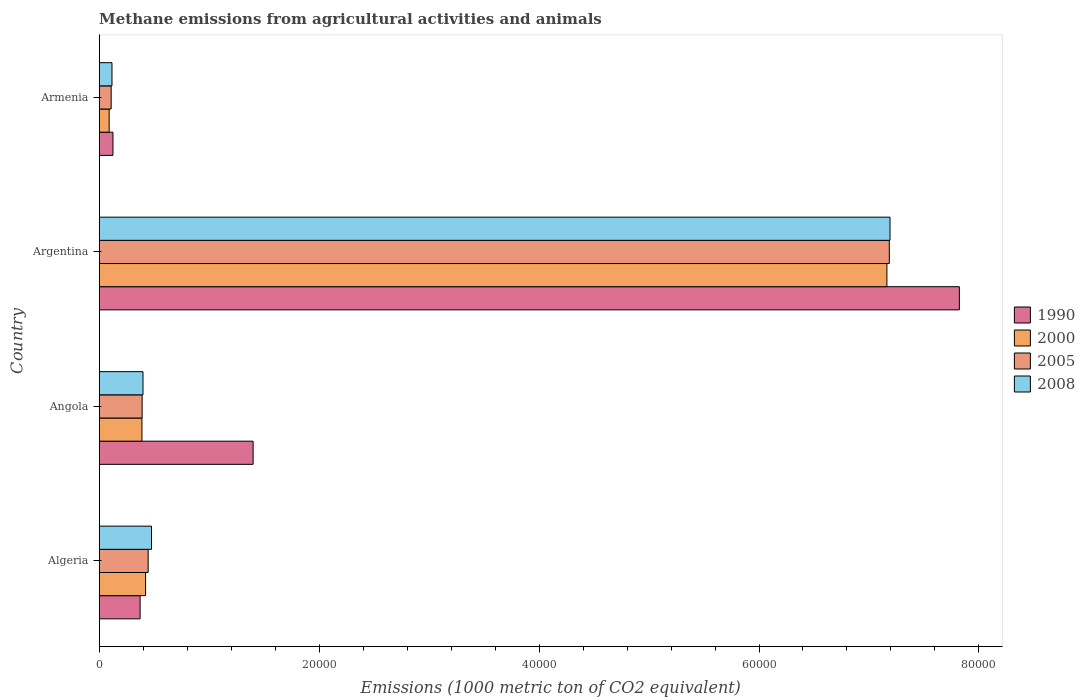Are the number of bars on each tick of the Y-axis equal?
Ensure brevity in your answer.  Yes. How many bars are there on the 4th tick from the top?
Your response must be concise. 4. How many bars are there on the 2nd tick from the bottom?
Offer a very short reply. 4. What is the label of the 1st group of bars from the top?
Offer a very short reply. Armenia. What is the amount of methane emitted in 2005 in Angola?
Your response must be concise. 3902.3. Across all countries, what is the maximum amount of methane emitted in 2008?
Make the answer very short. 7.19e+04. Across all countries, what is the minimum amount of methane emitted in 2005?
Provide a short and direct response. 1086. In which country was the amount of methane emitted in 2005 maximum?
Offer a terse response. Argentina. In which country was the amount of methane emitted in 2008 minimum?
Ensure brevity in your answer.  Armenia. What is the total amount of methane emitted in 1990 in the graph?
Offer a terse response. 9.72e+04. What is the difference between the amount of methane emitted in 1990 in Algeria and that in Angola?
Give a very brief answer. -1.03e+04. What is the difference between the amount of methane emitted in 2000 in Argentina and the amount of methane emitted in 2008 in Armenia?
Your answer should be compact. 7.05e+04. What is the average amount of methane emitted in 2005 per country?
Provide a short and direct response. 2.03e+04. What is the difference between the amount of methane emitted in 2000 and amount of methane emitted in 1990 in Argentina?
Offer a terse response. -6588.6. In how many countries, is the amount of methane emitted in 2005 greater than 12000 1000 metric ton?
Offer a very short reply. 1. What is the ratio of the amount of methane emitted in 1990 in Argentina to that in Armenia?
Provide a short and direct response. 62.56. Is the amount of methane emitted in 2005 in Algeria less than that in Argentina?
Make the answer very short. Yes. Is the difference between the amount of methane emitted in 2000 in Angola and Armenia greater than the difference between the amount of methane emitted in 1990 in Angola and Armenia?
Keep it short and to the point. No. What is the difference between the highest and the second highest amount of methane emitted in 2005?
Offer a very short reply. 6.74e+04. What is the difference between the highest and the lowest amount of methane emitted in 2005?
Offer a very short reply. 7.08e+04. In how many countries, is the amount of methane emitted in 1990 greater than the average amount of methane emitted in 1990 taken over all countries?
Offer a terse response. 1. Is the sum of the amount of methane emitted in 2005 in Algeria and Armenia greater than the maximum amount of methane emitted in 2000 across all countries?
Make the answer very short. No. What does the 2nd bar from the bottom in Armenia represents?
Your response must be concise. 2000. Is it the case that in every country, the sum of the amount of methane emitted in 1990 and amount of methane emitted in 2005 is greater than the amount of methane emitted in 2008?
Give a very brief answer. Yes. How many bars are there?
Offer a very short reply. 16. Are all the bars in the graph horizontal?
Provide a short and direct response. Yes. How many countries are there in the graph?
Provide a succinct answer. 4. Where does the legend appear in the graph?
Offer a very short reply. Center right. What is the title of the graph?
Your answer should be compact. Methane emissions from agricultural activities and animals. Does "2013" appear as one of the legend labels in the graph?
Give a very brief answer. No. What is the label or title of the X-axis?
Ensure brevity in your answer.  Emissions (1000 metric ton of CO2 equivalent). What is the label or title of the Y-axis?
Provide a succinct answer. Country. What is the Emissions (1000 metric ton of CO2 equivalent) in 1990 in Algeria?
Offer a very short reply. 3718.9. What is the Emissions (1000 metric ton of CO2 equivalent) of 2000 in Algeria?
Your answer should be very brief. 4216.3. What is the Emissions (1000 metric ton of CO2 equivalent) in 2005 in Algeria?
Ensure brevity in your answer.  4452.1. What is the Emissions (1000 metric ton of CO2 equivalent) of 2008 in Algeria?
Provide a succinct answer. 4754.7. What is the Emissions (1000 metric ton of CO2 equivalent) of 1990 in Angola?
Ensure brevity in your answer.  1.40e+04. What is the Emissions (1000 metric ton of CO2 equivalent) of 2000 in Angola?
Your answer should be very brief. 3884.4. What is the Emissions (1000 metric ton of CO2 equivalent) in 2005 in Angola?
Make the answer very short. 3902.3. What is the Emissions (1000 metric ton of CO2 equivalent) in 2008 in Angola?
Provide a succinct answer. 3982. What is the Emissions (1000 metric ton of CO2 equivalent) of 1990 in Argentina?
Give a very brief answer. 7.82e+04. What is the Emissions (1000 metric ton of CO2 equivalent) of 2000 in Argentina?
Ensure brevity in your answer.  7.16e+04. What is the Emissions (1000 metric ton of CO2 equivalent) of 2005 in Argentina?
Your response must be concise. 7.19e+04. What is the Emissions (1000 metric ton of CO2 equivalent) of 2008 in Argentina?
Ensure brevity in your answer.  7.19e+04. What is the Emissions (1000 metric ton of CO2 equivalent) of 1990 in Armenia?
Provide a short and direct response. 1250.4. What is the Emissions (1000 metric ton of CO2 equivalent) of 2000 in Armenia?
Ensure brevity in your answer.  903.1. What is the Emissions (1000 metric ton of CO2 equivalent) in 2005 in Armenia?
Your response must be concise. 1086. What is the Emissions (1000 metric ton of CO2 equivalent) in 2008 in Armenia?
Provide a short and direct response. 1161.5. Across all countries, what is the maximum Emissions (1000 metric ton of CO2 equivalent) in 1990?
Your answer should be very brief. 7.82e+04. Across all countries, what is the maximum Emissions (1000 metric ton of CO2 equivalent) of 2000?
Offer a terse response. 7.16e+04. Across all countries, what is the maximum Emissions (1000 metric ton of CO2 equivalent) of 2005?
Your response must be concise. 7.19e+04. Across all countries, what is the maximum Emissions (1000 metric ton of CO2 equivalent) in 2008?
Your response must be concise. 7.19e+04. Across all countries, what is the minimum Emissions (1000 metric ton of CO2 equivalent) of 1990?
Keep it short and to the point. 1250.4. Across all countries, what is the minimum Emissions (1000 metric ton of CO2 equivalent) in 2000?
Give a very brief answer. 903.1. Across all countries, what is the minimum Emissions (1000 metric ton of CO2 equivalent) of 2005?
Make the answer very short. 1086. Across all countries, what is the minimum Emissions (1000 metric ton of CO2 equivalent) of 2008?
Keep it short and to the point. 1161.5. What is the total Emissions (1000 metric ton of CO2 equivalent) in 1990 in the graph?
Your answer should be very brief. 9.72e+04. What is the total Emissions (1000 metric ton of CO2 equivalent) in 2000 in the graph?
Provide a short and direct response. 8.06e+04. What is the total Emissions (1000 metric ton of CO2 equivalent) in 2005 in the graph?
Provide a short and direct response. 8.13e+04. What is the total Emissions (1000 metric ton of CO2 equivalent) of 2008 in the graph?
Give a very brief answer. 8.18e+04. What is the difference between the Emissions (1000 metric ton of CO2 equivalent) in 1990 in Algeria and that in Angola?
Your answer should be compact. -1.03e+04. What is the difference between the Emissions (1000 metric ton of CO2 equivalent) in 2000 in Algeria and that in Angola?
Your answer should be compact. 331.9. What is the difference between the Emissions (1000 metric ton of CO2 equivalent) in 2005 in Algeria and that in Angola?
Give a very brief answer. 549.8. What is the difference between the Emissions (1000 metric ton of CO2 equivalent) in 2008 in Algeria and that in Angola?
Give a very brief answer. 772.7. What is the difference between the Emissions (1000 metric ton of CO2 equivalent) in 1990 in Algeria and that in Argentina?
Keep it short and to the point. -7.45e+04. What is the difference between the Emissions (1000 metric ton of CO2 equivalent) of 2000 in Algeria and that in Argentina?
Offer a terse response. -6.74e+04. What is the difference between the Emissions (1000 metric ton of CO2 equivalent) in 2005 in Algeria and that in Argentina?
Your response must be concise. -6.74e+04. What is the difference between the Emissions (1000 metric ton of CO2 equivalent) in 2008 in Algeria and that in Argentina?
Make the answer very short. -6.72e+04. What is the difference between the Emissions (1000 metric ton of CO2 equivalent) in 1990 in Algeria and that in Armenia?
Provide a short and direct response. 2468.5. What is the difference between the Emissions (1000 metric ton of CO2 equivalent) in 2000 in Algeria and that in Armenia?
Offer a very short reply. 3313.2. What is the difference between the Emissions (1000 metric ton of CO2 equivalent) in 2005 in Algeria and that in Armenia?
Offer a very short reply. 3366.1. What is the difference between the Emissions (1000 metric ton of CO2 equivalent) of 2008 in Algeria and that in Armenia?
Keep it short and to the point. 3593.2. What is the difference between the Emissions (1000 metric ton of CO2 equivalent) in 1990 in Angola and that in Argentina?
Ensure brevity in your answer.  -6.42e+04. What is the difference between the Emissions (1000 metric ton of CO2 equivalent) in 2000 in Angola and that in Argentina?
Provide a succinct answer. -6.77e+04. What is the difference between the Emissions (1000 metric ton of CO2 equivalent) in 2005 in Angola and that in Argentina?
Provide a short and direct response. -6.79e+04. What is the difference between the Emissions (1000 metric ton of CO2 equivalent) of 2008 in Angola and that in Argentina?
Provide a succinct answer. -6.79e+04. What is the difference between the Emissions (1000 metric ton of CO2 equivalent) in 1990 in Angola and that in Armenia?
Provide a succinct answer. 1.27e+04. What is the difference between the Emissions (1000 metric ton of CO2 equivalent) of 2000 in Angola and that in Armenia?
Provide a succinct answer. 2981.3. What is the difference between the Emissions (1000 metric ton of CO2 equivalent) in 2005 in Angola and that in Armenia?
Provide a short and direct response. 2816.3. What is the difference between the Emissions (1000 metric ton of CO2 equivalent) of 2008 in Angola and that in Armenia?
Give a very brief answer. 2820.5. What is the difference between the Emissions (1000 metric ton of CO2 equivalent) of 1990 in Argentina and that in Armenia?
Your answer should be compact. 7.70e+04. What is the difference between the Emissions (1000 metric ton of CO2 equivalent) of 2000 in Argentina and that in Armenia?
Make the answer very short. 7.07e+04. What is the difference between the Emissions (1000 metric ton of CO2 equivalent) of 2005 in Argentina and that in Armenia?
Your answer should be compact. 7.08e+04. What is the difference between the Emissions (1000 metric ton of CO2 equivalent) in 2008 in Argentina and that in Armenia?
Ensure brevity in your answer.  7.08e+04. What is the difference between the Emissions (1000 metric ton of CO2 equivalent) of 1990 in Algeria and the Emissions (1000 metric ton of CO2 equivalent) of 2000 in Angola?
Your answer should be compact. -165.5. What is the difference between the Emissions (1000 metric ton of CO2 equivalent) of 1990 in Algeria and the Emissions (1000 metric ton of CO2 equivalent) of 2005 in Angola?
Give a very brief answer. -183.4. What is the difference between the Emissions (1000 metric ton of CO2 equivalent) in 1990 in Algeria and the Emissions (1000 metric ton of CO2 equivalent) in 2008 in Angola?
Offer a very short reply. -263.1. What is the difference between the Emissions (1000 metric ton of CO2 equivalent) in 2000 in Algeria and the Emissions (1000 metric ton of CO2 equivalent) in 2005 in Angola?
Your answer should be very brief. 314. What is the difference between the Emissions (1000 metric ton of CO2 equivalent) of 2000 in Algeria and the Emissions (1000 metric ton of CO2 equivalent) of 2008 in Angola?
Keep it short and to the point. 234.3. What is the difference between the Emissions (1000 metric ton of CO2 equivalent) in 2005 in Algeria and the Emissions (1000 metric ton of CO2 equivalent) in 2008 in Angola?
Offer a very short reply. 470.1. What is the difference between the Emissions (1000 metric ton of CO2 equivalent) in 1990 in Algeria and the Emissions (1000 metric ton of CO2 equivalent) in 2000 in Argentina?
Offer a terse response. -6.79e+04. What is the difference between the Emissions (1000 metric ton of CO2 equivalent) in 1990 in Algeria and the Emissions (1000 metric ton of CO2 equivalent) in 2005 in Argentina?
Keep it short and to the point. -6.81e+04. What is the difference between the Emissions (1000 metric ton of CO2 equivalent) in 1990 in Algeria and the Emissions (1000 metric ton of CO2 equivalent) in 2008 in Argentina?
Your response must be concise. -6.82e+04. What is the difference between the Emissions (1000 metric ton of CO2 equivalent) in 2000 in Algeria and the Emissions (1000 metric ton of CO2 equivalent) in 2005 in Argentina?
Provide a short and direct response. -6.76e+04. What is the difference between the Emissions (1000 metric ton of CO2 equivalent) of 2000 in Algeria and the Emissions (1000 metric ton of CO2 equivalent) of 2008 in Argentina?
Keep it short and to the point. -6.77e+04. What is the difference between the Emissions (1000 metric ton of CO2 equivalent) of 2005 in Algeria and the Emissions (1000 metric ton of CO2 equivalent) of 2008 in Argentina?
Your answer should be very brief. -6.75e+04. What is the difference between the Emissions (1000 metric ton of CO2 equivalent) of 1990 in Algeria and the Emissions (1000 metric ton of CO2 equivalent) of 2000 in Armenia?
Your answer should be very brief. 2815.8. What is the difference between the Emissions (1000 metric ton of CO2 equivalent) of 1990 in Algeria and the Emissions (1000 metric ton of CO2 equivalent) of 2005 in Armenia?
Your answer should be compact. 2632.9. What is the difference between the Emissions (1000 metric ton of CO2 equivalent) in 1990 in Algeria and the Emissions (1000 metric ton of CO2 equivalent) in 2008 in Armenia?
Your answer should be very brief. 2557.4. What is the difference between the Emissions (1000 metric ton of CO2 equivalent) in 2000 in Algeria and the Emissions (1000 metric ton of CO2 equivalent) in 2005 in Armenia?
Offer a very short reply. 3130.3. What is the difference between the Emissions (1000 metric ton of CO2 equivalent) of 2000 in Algeria and the Emissions (1000 metric ton of CO2 equivalent) of 2008 in Armenia?
Your answer should be compact. 3054.8. What is the difference between the Emissions (1000 metric ton of CO2 equivalent) in 2005 in Algeria and the Emissions (1000 metric ton of CO2 equivalent) in 2008 in Armenia?
Your response must be concise. 3290.6. What is the difference between the Emissions (1000 metric ton of CO2 equivalent) in 1990 in Angola and the Emissions (1000 metric ton of CO2 equivalent) in 2000 in Argentina?
Provide a succinct answer. -5.76e+04. What is the difference between the Emissions (1000 metric ton of CO2 equivalent) of 1990 in Angola and the Emissions (1000 metric ton of CO2 equivalent) of 2005 in Argentina?
Give a very brief answer. -5.79e+04. What is the difference between the Emissions (1000 metric ton of CO2 equivalent) in 1990 in Angola and the Emissions (1000 metric ton of CO2 equivalent) in 2008 in Argentina?
Provide a short and direct response. -5.79e+04. What is the difference between the Emissions (1000 metric ton of CO2 equivalent) in 2000 in Angola and the Emissions (1000 metric ton of CO2 equivalent) in 2005 in Argentina?
Offer a terse response. -6.80e+04. What is the difference between the Emissions (1000 metric ton of CO2 equivalent) in 2000 in Angola and the Emissions (1000 metric ton of CO2 equivalent) in 2008 in Argentina?
Give a very brief answer. -6.80e+04. What is the difference between the Emissions (1000 metric ton of CO2 equivalent) of 2005 in Angola and the Emissions (1000 metric ton of CO2 equivalent) of 2008 in Argentina?
Make the answer very short. -6.80e+04. What is the difference between the Emissions (1000 metric ton of CO2 equivalent) of 1990 in Angola and the Emissions (1000 metric ton of CO2 equivalent) of 2000 in Armenia?
Provide a short and direct response. 1.31e+04. What is the difference between the Emissions (1000 metric ton of CO2 equivalent) in 1990 in Angola and the Emissions (1000 metric ton of CO2 equivalent) in 2005 in Armenia?
Provide a succinct answer. 1.29e+04. What is the difference between the Emissions (1000 metric ton of CO2 equivalent) in 1990 in Angola and the Emissions (1000 metric ton of CO2 equivalent) in 2008 in Armenia?
Your answer should be very brief. 1.28e+04. What is the difference between the Emissions (1000 metric ton of CO2 equivalent) of 2000 in Angola and the Emissions (1000 metric ton of CO2 equivalent) of 2005 in Armenia?
Offer a very short reply. 2798.4. What is the difference between the Emissions (1000 metric ton of CO2 equivalent) in 2000 in Angola and the Emissions (1000 metric ton of CO2 equivalent) in 2008 in Armenia?
Your response must be concise. 2722.9. What is the difference between the Emissions (1000 metric ton of CO2 equivalent) in 2005 in Angola and the Emissions (1000 metric ton of CO2 equivalent) in 2008 in Armenia?
Offer a terse response. 2740.8. What is the difference between the Emissions (1000 metric ton of CO2 equivalent) in 1990 in Argentina and the Emissions (1000 metric ton of CO2 equivalent) in 2000 in Armenia?
Provide a succinct answer. 7.73e+04. What is the difference between the Emissions (1000 metric ton of CO2 equivalent) of 1990 in Argentina and the Emissions (1000 metric ton of CO2 equivalent) of 2005 in Armenia?
Your response must be concise. 7.71e+04. What is the difference between the Emissions (1000 metric ton of CO2 equivalent) of 1990 in Argentina and the Emissions (1000 metric ton of CO2 equivalent) of 2008 in Armenia?
Offer a terse response. 7.71e+04. What is the difference between the Emissions (1000 metric ton of CO2 equivalent) of 2000 in Argentina and the Emissions (1000 metric ton of CO2 equivalent) of 2005 in Armenia?
Give a very brief answer. 7.05e+04. What is the difference between the Emissions (1000 metric ton of CO2 equivalent) of 2000 in Argentina and the Emissions (1000 metric ton of CO2 equivalent) of 2008 in Armenia?
Keep it short and to the point. 7.05e+04. What is the difference between the Emissions (1000 metric ton of CO2 equivalent) in 2005 in Argentina and the Emissions (1000 metric ton of CO2 equivalent) in 2008 in Armenia?
Give a very brief answer. 7.07e+04. What is the average Emissions (1000 metric ton of CO2 equivalent) of 1990 per country?
Make the answer very short. 2.43e+04. What is the average Emissions (1000 metric ton of CO2 equivalent) in 2000 per country?
Offer a very short reply. 2.02e+04. What is the average Emissions (1000 metric ton of CO2 equivalent) of 2005 per country?
Your response must be concise. 2.03e+04. What is the average Emissions (1000 metric ton of CO2 equivalent) in 2008 per country?
Provide a short and direct response. 2.05e+04. What is the difference between the Emissions (1000 metric ton of CO2 equivalent) of 1990 and Emissions (1000 metric ton of CO2 equivalent) of 2000 in Algeria?
Your answer should be very brief. -497.4. What is the difference between the Emissions (1000 metric ton of CO2 equivalent) in 1990 and Emissions (1000 metric ton of CO2 equivalent) in 2005 in Algeria?
Provide a succinct answer. -733.2. What is the difference between the Emissions (1000 metric ton of CO2 equivalent) of 1990 and Emissions (1000 metric ton of CO2 equivalent) of 2008 in Algeria?
Provide a succinct answer. -1035.8. What is the difference between the Emissions (1000 metric ton of CO2 equivalent) in 2000 and Emissions (1000 metric ton of CO2 equivalent) in 2005 in Algeria?
Offer a very short reply. -235.8. What is the difference between the Emissions (1000 metric ton of CO2 equivalent) of 2000 and Emissions (1000 metric ton of CO2 equivalent) of 2008 in Algeria?
Offer a very short reply. -538.4. What is the difference between the Emissions (1000 metric ton of CO2 equivalent) in 2005 and Emissions (1000 metric ton of CO2 equivalent) in 2008 in Algeria?
Make the answer very short. -302.6. What is the difference between the Emissions (1000 metric ton of CO2 equivalent) of 1990 and Emissions (1000 metric ton of CO2 equivalent) of 2000 in Angola?
Offer a terse response. 1.01e+04. What is the difference between the Emissions (1000 metric ton of CO2 equivalent) of 1990 and Emissions (1000 metric ton of CO2 equivalent) of 2005 in Angola?
Provide a short and direct response. 1.01e+04. What is the difference between the Emissions (1000 metric ton of CO2 equivalent) of 1990 and Emissions (1000 metric ton of CO2 equivalent) of 2008 in Angola?
Ensure brevity in your answer.  1.00e+04. What is the difference between the Emissions (1000 metric ton of CO2 equivalent) of 2000 and Emissions (1000 metric ton of CO2 equivalent) of 2005 in Angola?
Give a very brief answer. -17.9. What is the difference between the Emissions (1000 metric ton of CO2 equivalent) in 2000 and Emissions (1000 metric ton of CO2 equivalent) in 2008 in Angola?
Provide a succinct answer. -97.6. What is the difference between the Emissions (1000 metric ton of CO2 equivalent) in 2005 and Emissions (1000 metric ton of CO2 equivalent) in 2008 in Angola?
Your answer should be compact. -79.7. What is the difference between the Emissions (1000 metric ton of CO2 equivalent) of 1990 and Emissions (1000 metric ton of CO2 equivalent) of 2000 in Argentina?
Keep it short and to the point. 6588.6. What is the difference between the Emissions (1000 metric ton of CO2 equivalent) of 1990 and Emissions (1000 metric ton of CO2 equivalent) of 2005 in Argentina?
Your response must be concise. 6369.6. What is the difference between the Emissions (1000 metric ton of CO2 equivalent) of 1990 and Emissions (1000 metric ton of CO2 equivalent) of 2008 in Argentina?
Keep it short and to the point. 6305.5. What is the difference between the Emissions (1000 metric ton of CO2 equivalent) in 2000 and Emissions (1000 metric ton of CO2 equivalent) in 2005 in Argentina?
Your answer should be compact. -219. What is the difference between the Emissions (1000 metric ton of CO2 equivalent) in 2000 and Emissions (1000 metric ton of CO2 equivalent) in 2008 in Argentina?
Ensure brevity in your answer.  -283.1. What is the difference between the Emissions (1000 metric ton of CO2 equivalent) of 2005 and Emissions (1000 metric ton of CO2 equivalent) of 2008 in Argentina?
Keep it short and to the point. -64.1. What is the difference between the Emissions (1000 metric ton of CO2 equivalent) in 1990 and Emissions (1000 metric ton of CO2 equivalent) in 2000 in Armenia?
Your response must be concise. 347.3. What is the difference between the Emissions (1000 metric ton of CO2 equivalent) of 1990 and Emissions (1000 metric ton of CO2 equivalent) of 2005 in Armenia?
Your answer should be compact. 164.4. What is the difference between the Emissions (1000 metric ton of CO2 equivalent) of 1990 and Emissions (1000 metric ton of CO2 equivalent) of 2008 in Armenia?
Give a very brief answer. 88.9. What is the difference between the Emissions (1000 metric ton of CO2 equivalent) in 2000 and Emissions (1000 metric ton of CO2 equivalent) in 2005 in Armenia?
Ensure brevity in your answer.  -182.9. What is the difference between the Emissions (1000 metric ton of CO2 equivalent) of 2000 and Emissions (1000 metric ton of CO2 equivalent) of 2008 in Armenia?
Provide a succinct answer. -258.4. What is the difference between the Emissions (1000 metric ton of CO2 equivalent) of 2005 and Emissions (1000 metric ton of CO2 equivalent) of 2008 in Armenia?
Provide a succinct answer. -75.5. What is the ratio of the Emissions (1000 metric ton of CO2 equivalent) of 1990 in Algeria to that in Angola?
Provide a succinct answer. 0.27. What is the ratio of the Emissions (1000 metric ton of CO2 equivalent) in 2000 in Algeria to that in Angola?
Your answer should be very brief. 1.09. What is the ratio of the Emissions (1000 metric ton of CO2 equivalent) in 2005 in Algeria to that in Angola?
Your answer should be very brief. 1.14. What is the ratio of the Emissions (1000 metric ton of CO2 equivalent) of 2008 in Algeria to that in Angola?
Your answer should be compact. 1.19. What is the ratio of the Emissions (1000 metric ton of CO2 equivalent) in 1990 in Algeria to that in Argentina?
Offer a terse response. 0.05. What is the ratio of the Emissions (1000 metric ton of CO2 equivalent) in 2000 in Algeria to that in Argentina?
Give a very brief answer. 0.06. What is the ratio of the Emissions (1000 metric ton of CO2 equivalent) of 2005 in Algeria to that in Argentina?
Your answer should be compact. 0.06. What is the ratio of the Emissions (1000 metric ton of CO2 equivalent) in 2008 in Algeria to that in Argentina?
Provide a short and direct response. 0.07. What is the ratio of the Emissions (1000 metric ton of CO2 equivalent) in 1990 in Algeria to that in Armenia?
Keep it short and to the point. 2.97. What is the ratio of the Emissions (1000 metric ton of CO2 equivalent) of 2000 in Algeria to that in Armenia?
Your answer should be compact. 4.67. What is the ratio of the Emissions (1000 metric ton of CO2 equivalent) in 2005 in Algeria to that in Armenia?
Offer a very short reply. 4.1. What is the ratio of the Emissions (1000 metric ton of CO2 equivalent) in 2008 in Algeria to that in Armenia?
Your answer should be very brief. 4.09. What is the ratio of the Emissions (1000 metric ton of CO2 equivalent) in 1990 in Angola to that in Argentina?
Ensure brevity in your answer.  0.18. What is the ratio of the Emissions (1000 metric ton of CO2 equivalent) of 2000 in Angola to that in Argentina?
Your response must be concise. 0.05. What is the ratio of the Emissions (1000 metric ton of CO2 equivalent) in 2005 in Angola to that in Argentina?
Your answer should be compact. 0.05. What is the ratio of the Emissions (1000 metric ton of CO2 equivalent) in 2008 in Angola to that in Argentina?
Your answer should be very brief. 0.06. What is the ratio of the Emissions (1000 metric ton of CO2 equivalent) of 1990 in Angola to that in Armenia?
Offer a very short reply. 11.19. What is the ratio of the Emissions (1000 metric ton of CO2 equivalent) in 2000 in Angola to that in Armenia?
Keep it short and to the point. 4.3. What is the ratio of the Emissions (1000 metric ton of CO2 equivalent) of 2005 in Angola to that in Armenia?
Give a very brief answer. 3.59. What is the ratio of the Emissions (1000 metric ton of CO2 equivalent) in 2008 in Angola to that in Armenia?
Your response must be concise. 3.43. What is the ratio of the Emissions (1000 metric ton of CO2 equivalent) in 1990 in Argentina to that in Armenia?
Provide a short and direct response. 62.56. What is the ratio of the Emissions (1000 metric ton of CO2 equivalent) of 2000 in Argentina to that in Armenia?
Your answer should be very brief. 79.32. What is the ratio of the Emissions (1000 metric ton of CO2 equivalent) in 2005 in Argentina to that in Armenia?
Your answer should be very brief. 66.16. What is the ratio of the Emissions (1000 metric ton of CO2 equivalent) in 2008 in Argentina to that in Armenia?
Your response must be concise. 61.92. What is the difference between the highest and the second highest Emissions (1000 metric ton of CO2 equivalent) in 1990?
Make the answer very short. 6.42e+04. What is the difference between the highest and the second highest Emissions (1000 metric ton of CO2 equivalent) in 2000?
Keep it short and to the point. 6.74e+04. What is the difference between the highest and the second highest Emissions (1000 metric ton of CO2 equivalent) in 2005?
Your response must be concise. 6.74e+04. What is the difference between the highest and the second highest Emissions (1000 metric ton of CO2 equivalent) in 2008?
Keep it short and to the point. 6.72e+04. What is the difference between the highest and the lowest Emissions (1000 metric ton of CO2 equivalent) of 1990?
Keep it short and to the point. 7.70e+04. What is the difference between the highest and the lowest Emissions (1000 metric ton of CO2 equivalent) of 2000?
Provide a short and direct response. 7.07e+04. What is the difference between the highest and the lowest Emissions (1000 metric ton of CO2 equivalent) in 2005?
Your response must be concise. 7.08e+04. What is the difference between the highest and the lowest Emissions (1000 metric ton of CO2 equivalent) in 2008?
Your response must be concise. 7.08e+04. 